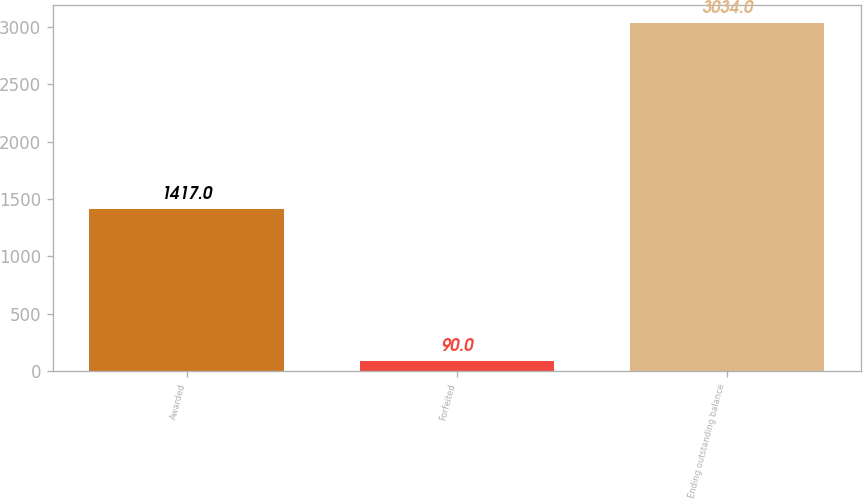Convert chart to OTSL. <chart><loc_0><loc_0><loc_500><loc_500><bar_chart><fcel>Awarded<fcel>Forfeited<fcel>Ending outstanding balance<nl><fcel>1417<fcel>90<fcel>3034<nl></chart> 